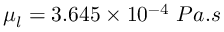<formula> <loc_0><loc_0><loc_500><loc_500>\mu _ { l } = 3 . 6 4 5 \times 1 0 ^ { - 4 } P a . s</formula> 